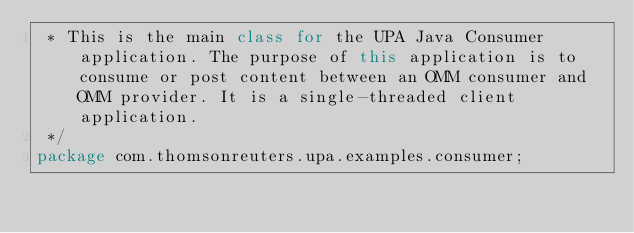Convert code to text. <code><loc_0><loc_0><loc_500><loc_500><_Java_> * This is the main class for the UPA Java Consumer application. The purpose of this application is to consume or post content between an OMM consumer and OMM provider. It is a single-threaded client application.
 */
package com.thomsonreuters.upa.examples.consumer;</code> 